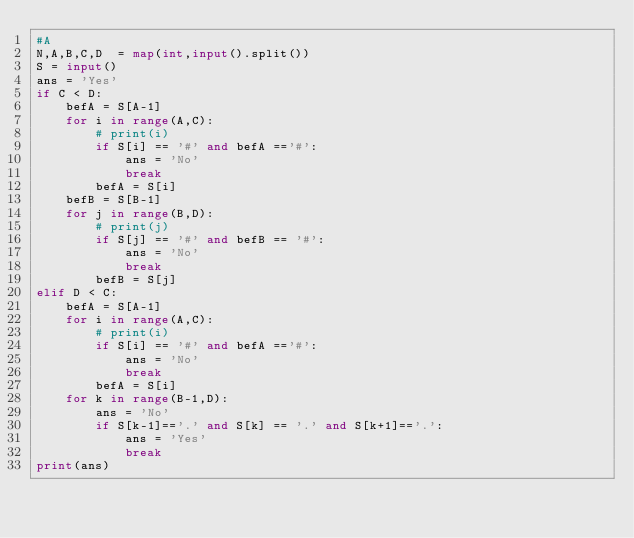<code> <loc_0><loc_0><loc_500><loc_500><_Python_>#A
N,A,B,C,D  = map(int,input().split())
S = input()
ans = 'Yes'
if C < D:
    befA = S[A-1]
    for i in range(A,C):
        # print(i)
        if S[i] == '#' and befA =='#':
            ans = 'No'
            break
        befA = S[i]
    befB = S[B-1]
    for j in range(B,D):
        # print(j)
        if S[j] == '#' and befB == '#':
            ans = 'No'
            break
        befB = S[j]
elif D < C:
    befA = S[A-1]
    for i in range(A,C):
        # print(i)
        if S[i] == '#' and befA =='#':
            ans = 'No'
            break
        befA = S[i]
    for k in range(B-1,D):
        ans = 'No'
        if S[k-1]=='.' and S[k] == '.' and S[k+1]=='.':
            ans = 'Yes'
            break
print(ans)</code> 